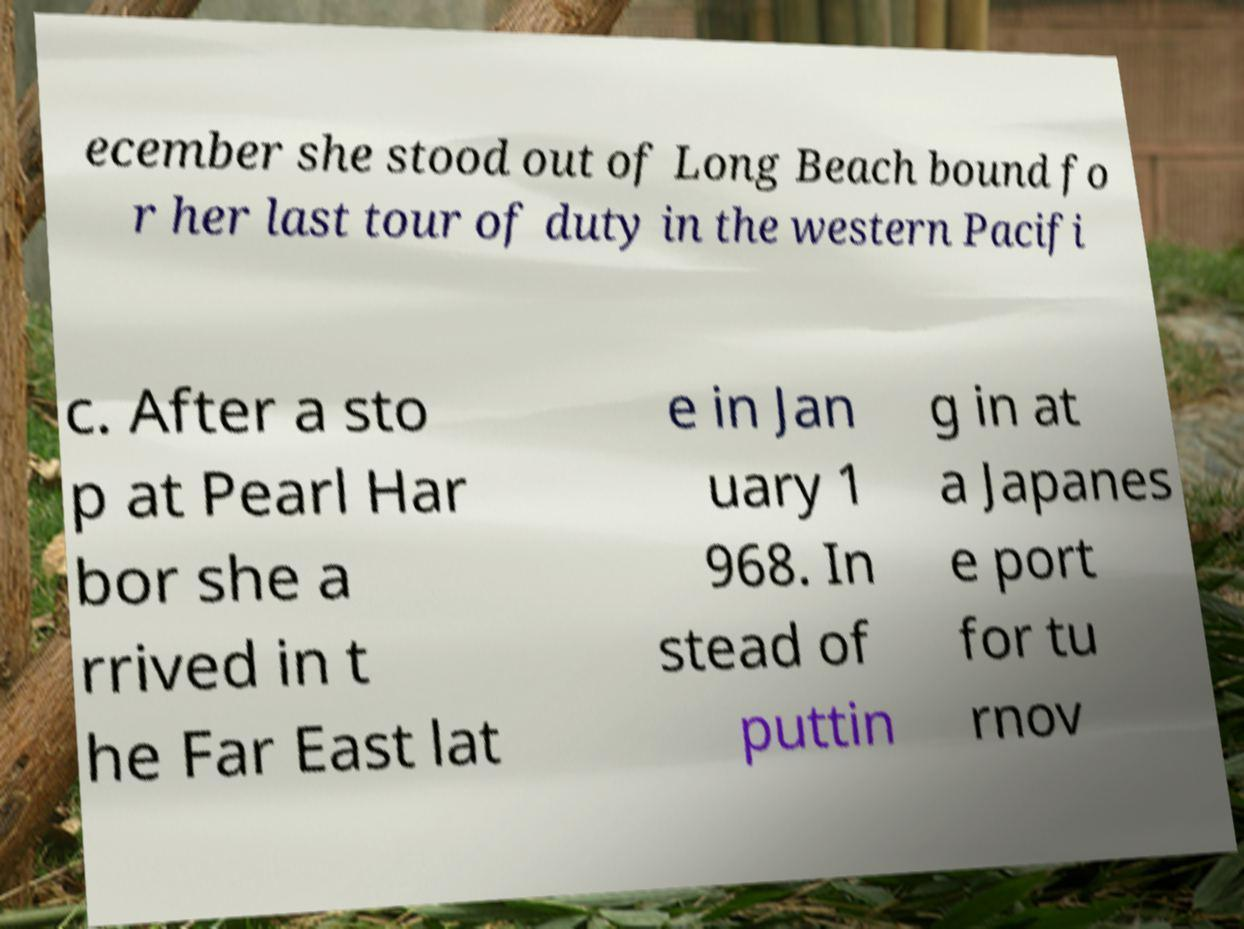I need the written content from this picture converted into text. Can you do that? ecember she stood out of Long Beach bound fo r her last tour of duty in the western Pacifi c. After a sto p at Pearl Har bor she a rrived in t he Far East lat e in Jan uary 1 968. In stead of puttin g in at a Japanes e port for tu rnov 